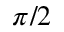Convert formula to latex. <formula><loc_0><loc_0><loc_500><loc_500>\pi / 2</formula> 